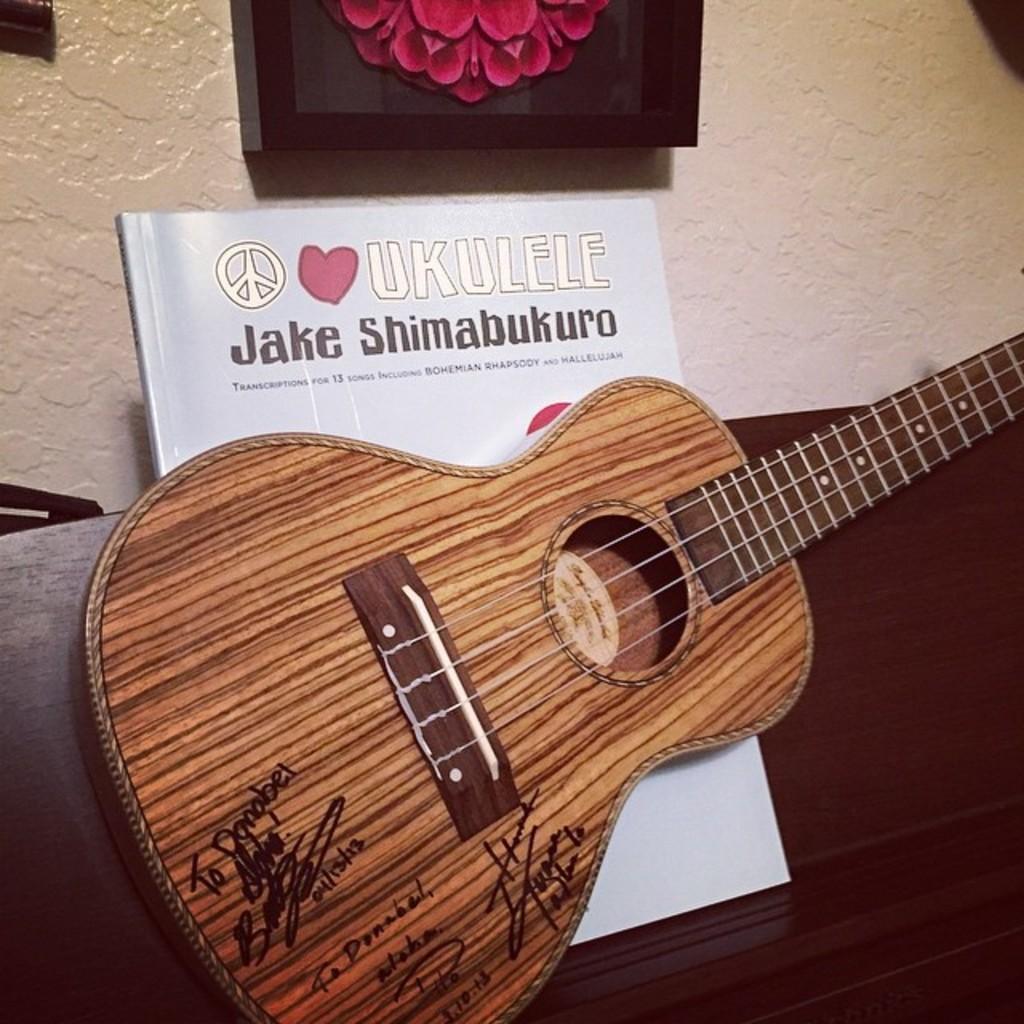Please provide a concise description of this image. In this image, There is a table which is in brown color and on that table there is a music instrument which is in yellow color and there is a book which is in white color, In the background there is a floor in yellow color. 